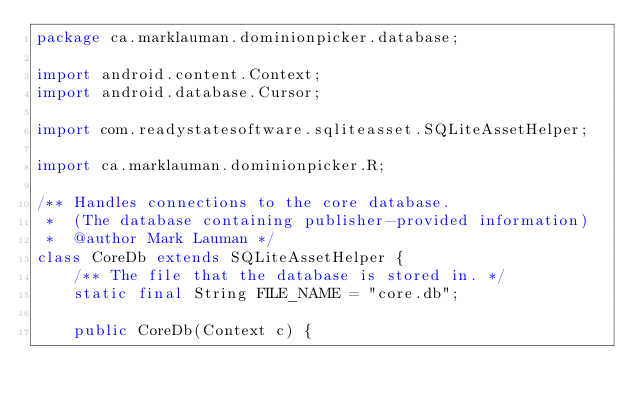Convert code to text. <code><loc_0><loc_0><loc_500><loc_500><_Java_>package ca.marklauman.dominionpicker.database;

import android.content.Context;
import android.database.Cursor;

import com.readystatesoftware.sqliteasset.SQLiteAssetHelper;

import ca.marklauman.dominionpicker.R;

/** Handles connections to the core database.
 *  (The database containing publisher-provided information)
 *  @author Mark Lauman */
class CoreDb extends SQLiteAssetHelper {
    /** The file that the database is stored in. */
    static final String FILE_NAME = "core.db";

    public CoreDb(Context c) {</code> 